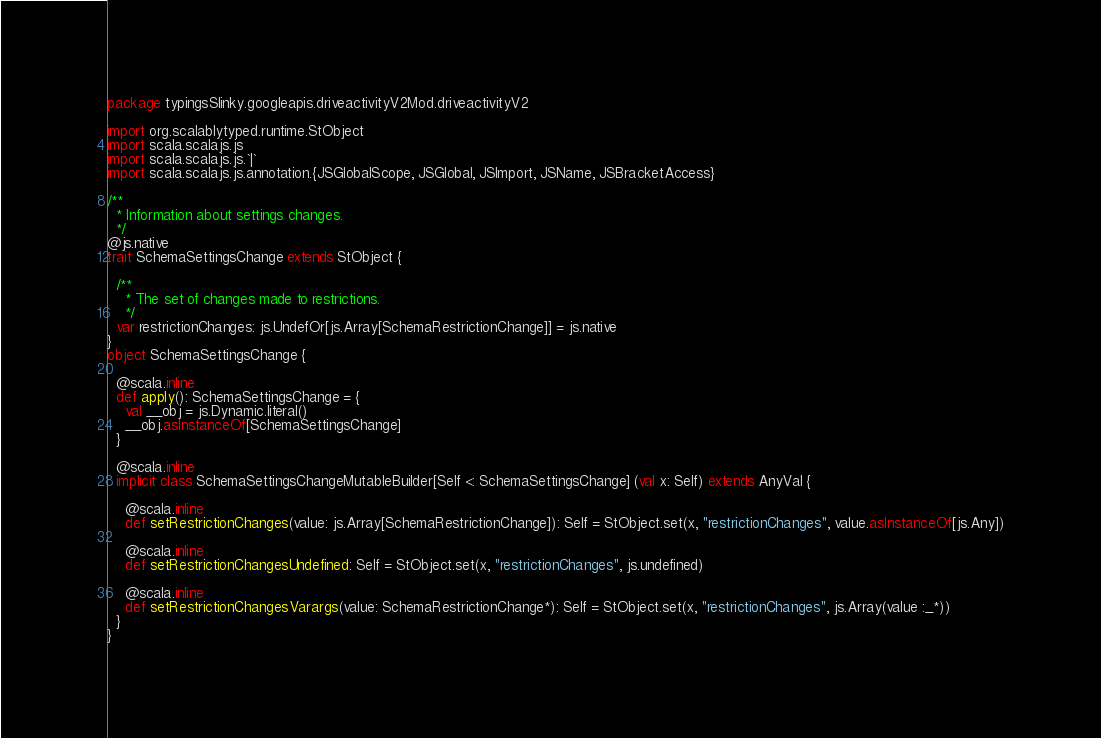<code> <loc_0><loc_0><loc_500><loc_500><_Scala_>package typingsSlinky.googleapis.driveactivityV2Mod.driveactivityV2

import org.scalablytyped.runtime.StObject
import scala.scalajs.js
import scala.scalajs.js.`|`
import scala.scalajs.js.annotation.{JSGlobalScope, JSGlobal, JSImport, JSName, JSBracketAccess}

/**
  * Information about settings changes.
  */
@js.native
trait SchemaSettingsChange extends StObject {
  
  /**
    * The set of changes made to restrictions.
    */
  var restrictionChanges: js.UndefOr[js.Array[SchemaRestrictionChange]] = js.native
}
object SchemaSettingsChange {
  
  @scala.inline
  def apply(): SchemaSettingsChange = {
    val __obj = js.Dynamic.literal()
    __obj.asInstanceOf[SchemaSettingsChange]
  }
  
  @scala.inline
  implicit class SchemaSettingsChangeMutableBuilder[Self <: SchemaSettingsChange] (val x: Self) extends AnyVal {
    
    @scala.inline
    def setRestrictionChanges(value: js.Array[SchemaRestrictionChange]): Self = StObject.set(x, "restrictionChanges", value.asInstanceOf[js.Any])
    
    @scala.inline
    def setRestrictionChangesUndefined: Self = StObject.set(x, "restrictionChanges", js.undefined)
    
    @scala.inline
    def setRestrictionChangesVarargs(value: SchemaRestrictionChange*): Self = StObject.set(x, "restrictionChanges", js.Array(value :_*))
  }
}
</code> 